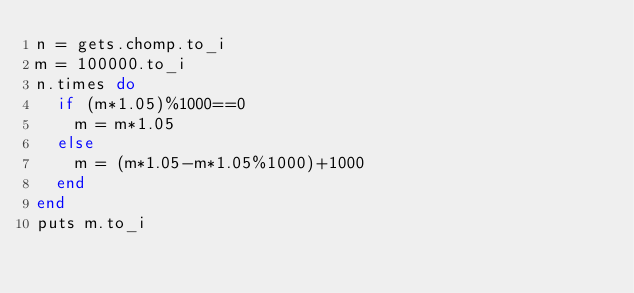Convert code to text. <code><loc_0><loc_0><loc_500><loc_500><_Ruby_>n = gets.chomp.to_i
m = 100000.to_i
n.times do
  if (m*1.05)%1000==0
    m = m*1.05
  else
    m = (m*1.05-m*1.05%1000)+1000
  end
end
puts m.to_i</code> 